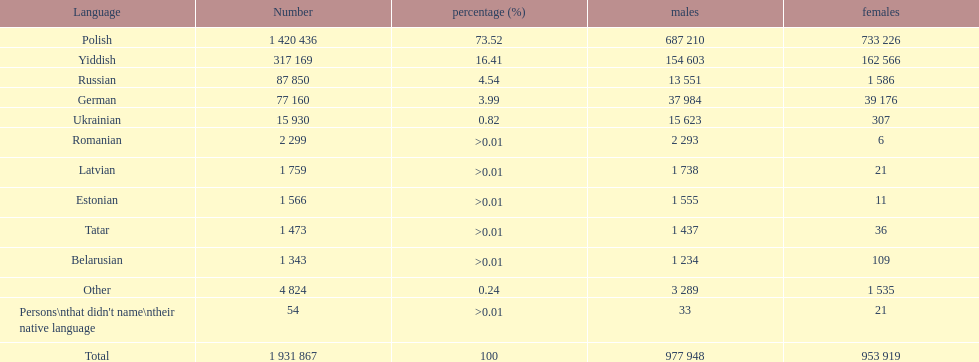What is the highest percentage of speakers other than polish? Yiddish. 